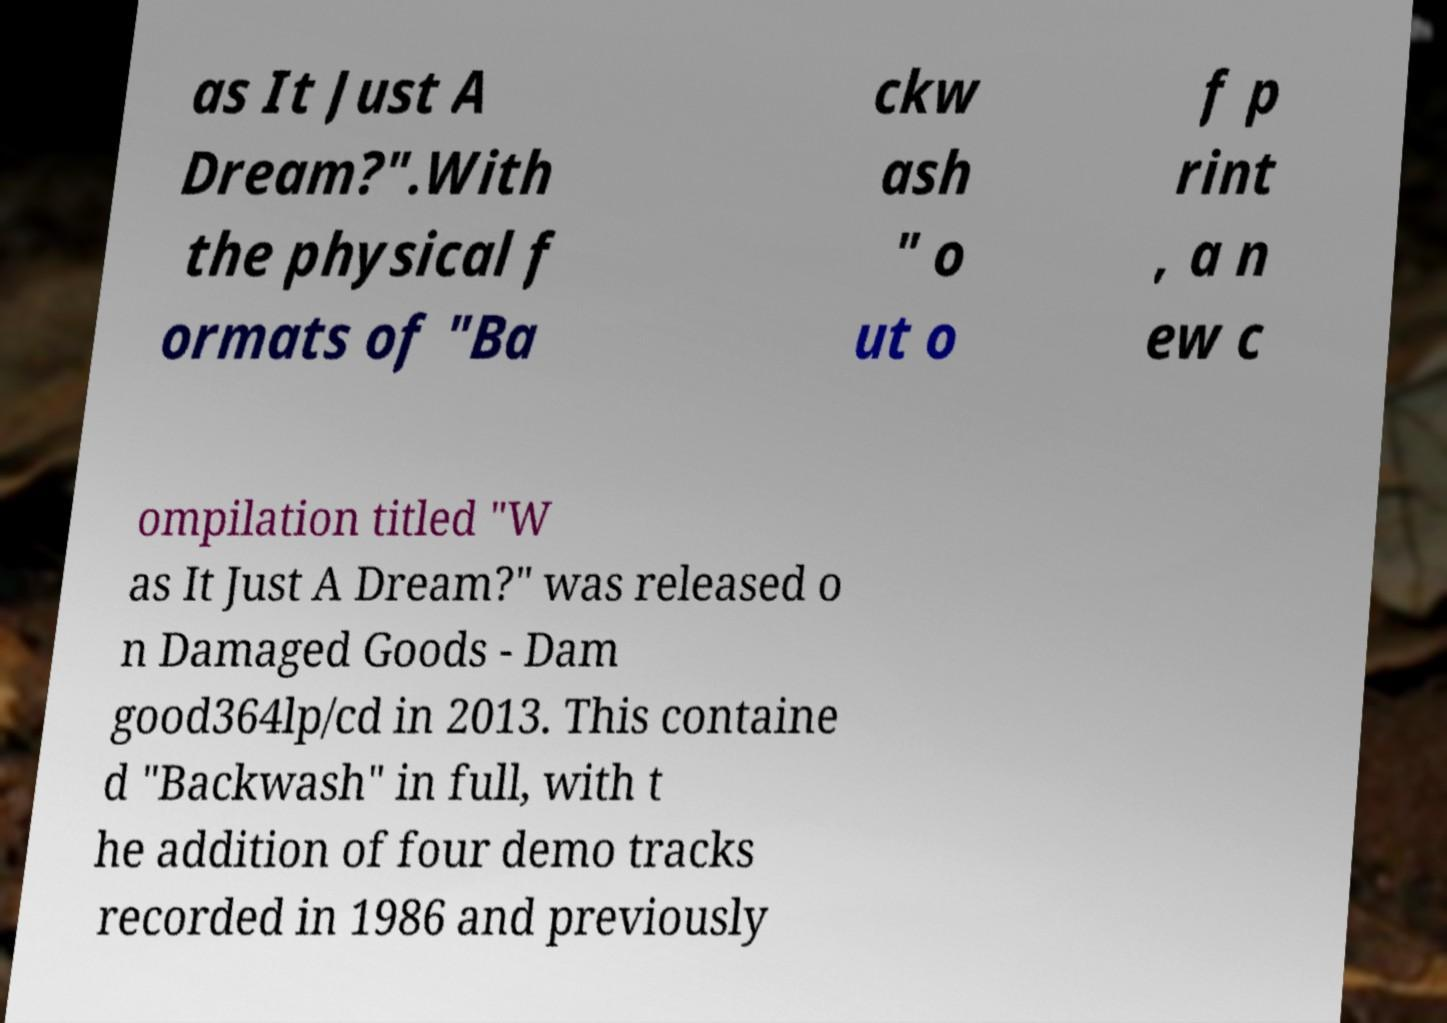What messages or text are displayed in this image? I need them in a readable, typed format. as It Just A Dream?".With the physical f ormats of "Ba ckw ash " o ut o f p rint , a n ew c ompilation titled "W as It Just A Dream?" was released o n Damaged Goods - Dam good364lp/cd in 2013. This containe d "Backwash" in full, with t he addition of four demo tracks recorded in 1986 and previously 